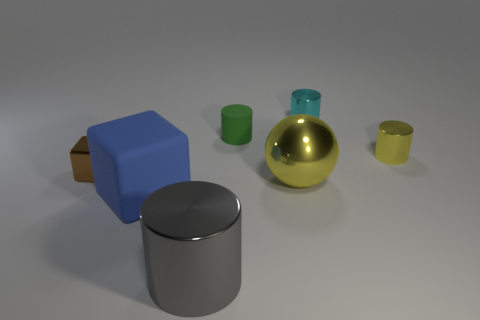Does the large sphere have the same material as the tiny brown block?
Your response must be concise. Yes. What number of blocks are small cyan metal objects or tiny metallic objects?
Your response must be concise. 1. There is a blue rubber block that is in front of the tiny metallic object left of the yellow metal thing left of the tiny yellow thing; what size is it?
Keep it short and to the point. Large. There is a blue thing that is the same shape as the tiny brown metal thing; what is its size?
Give a very brief answer. Large. There is a green thing; how many big blue matte things are in front of it?
Offer a terse response. 1. Do the cylinder that is in front of the blue object and the sphere have the same color?
Offer a very short reply. No. What number of cyan things are either tiny objects or tiny metallic objects?
Offer a very short reply. 1. What color is the rubber object that is left of the cylinder that is in front of the brown metallic object?
Offer a terse response. Blue. There is a small thing that is the same color as the large sphere; what is it made of?
Offer a terse response. Metal. What is the color of the small metal cylinder behind the matte cylinder?
Ensure brevity in your answer.  Cyan. 